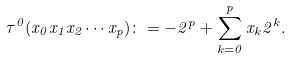<formula> <loc_0><loc_0><loc_500><loc_500>\tau ^ { 0 } ( x _ { 0 } x _ { 1 } x _ { 2 } \cdots x _ { p } ) \colon = - 2 ^ { p } + \sum _ { k = 0 } ^ { p } x _ { k } 2 ^ { k } .</formula> 